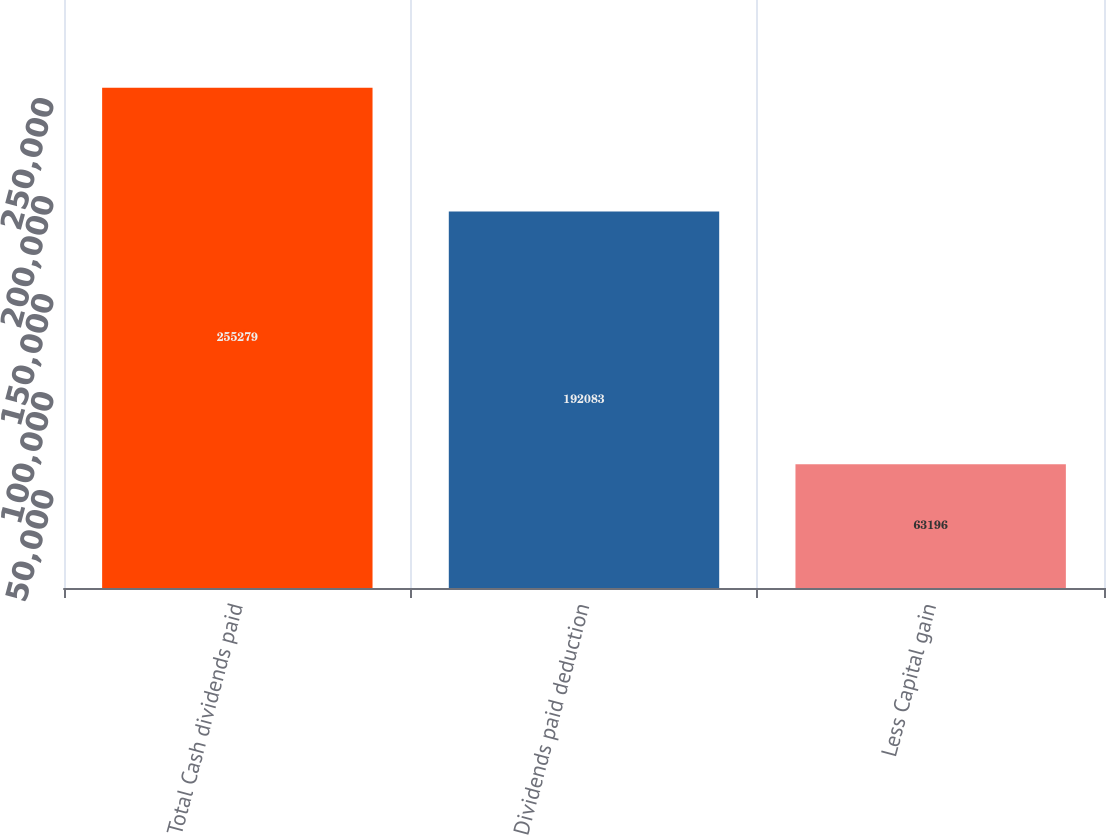Convert chart. <chart><loc_0><loc_0><loc_500><loc_500><bar_chart><fcel>Total Cash dividends paid<fcel>Dividends paid deduction<fcel>Less Capital gain<nl><fcel>255279<fcel>192083<fcel>63196<nl></chart> 